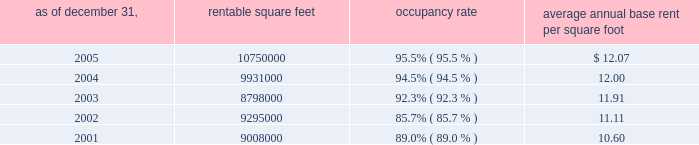Properties 33vornado realty trust supermarkets , home improvement stores , discount apparel stores and membership warehouse clubs .
Tenants typically offer basic consumer necessities such as food , health and beauty aids , moderately priced clothing , building materials and home improvement supplies , and compete primarily on the basis of price and location .
Regional malls : the green acres mall in long island , new york contains 1.6 million square feet , and is anchored by four major department stores : sears , j.c .
Penney , federated department stores , doing business as macy 2019s and macy 2019s men 2019s furniture gallery .
The complex also includes the plaza at green acres , a 175000 square foot strip shopping center which is anchored by wal-mart and national wholesale liquidators .
The company plans to renovate the interior and exterior of the mall and construct 100000 square feet of free-standing retail space and parking decks in the complex , subject to governmental approvals .
In addition , the company has entered into a ground lease with b.j . 2019s wholesale club who will construct its own free-standing store in the mall complex .
The expansion and renovation are expected to be completed in 2007 .
The monmouth mall in eatontown , new jersey , owned 50% ( 50 % ) by the company , contains 1.4 million square feet and is anchored by four department stores ; macy 2019s , lord & taylor , j.c .
Penney and boscovs , three of which own their stores aggregating 719000 square feet .
The joint venture plans to construct 80000 square feet of free-standing retail space in the mall complex , subject to governmental approvals .
The expansion is expected to be completed in 2007 .
The broadway mall in hicksville , long island , new york , contains 1.2 million square feet and is anchored by macy 2019s , ikea , multiplex cinema and target , which owns its store containing 141000 square feet .
The bergen mall in paramus , new jersey , as currently exists , contains 900000 square feet .
The company plans to demolish approximately 300000 square feet and construct approximately 580000 square feet of retail space , which will bring the total square footage of the mall to approximately 1360000 , including 180000 square feet to be built by target on land leased from the company .
As of december 31 , 2005 , the company has taken 480000 square feet out of service for redevelopment and leased 236000 square feet to century 21 and whole foods .
All of the foregoing is subject to governmental approvals .
The expansion and renovations , as planned , are expected to be completed in 2008 .
The montehiedra mall in san juan , puerto rico , contains 563000 square feet and is anchored by home depot , kmart , and marshalls .
The south hills mall in poughkeepsie , new york , contains 668000 square feet and is anchored by kmart and burlington coat factory .
The company plans to redevelop and retenant the mall , subject to governmental approvals .
The las catalinas mall in san juan , puerto rico , contains 495000 square feet and is anchored by kmart and sears , which owns its 140000 square foot store .
Occupancy and average annual base rent per square foot : at december 31 , 2005 , the aggregate occupancy rate for the 16169000 square feet of retail properties was 95.6% ( 95.6 % ) .
Strip shopping centers : average annual rentable base rent as of december 31 , square feet occupancy rate per square foot .

For the the bergen mall in paramus , new jersey , approximately what percentage will be the square feet to be built by target on land leased from the company? 
Computations: (180000 / 1360000)
Answer: 0.13235. 